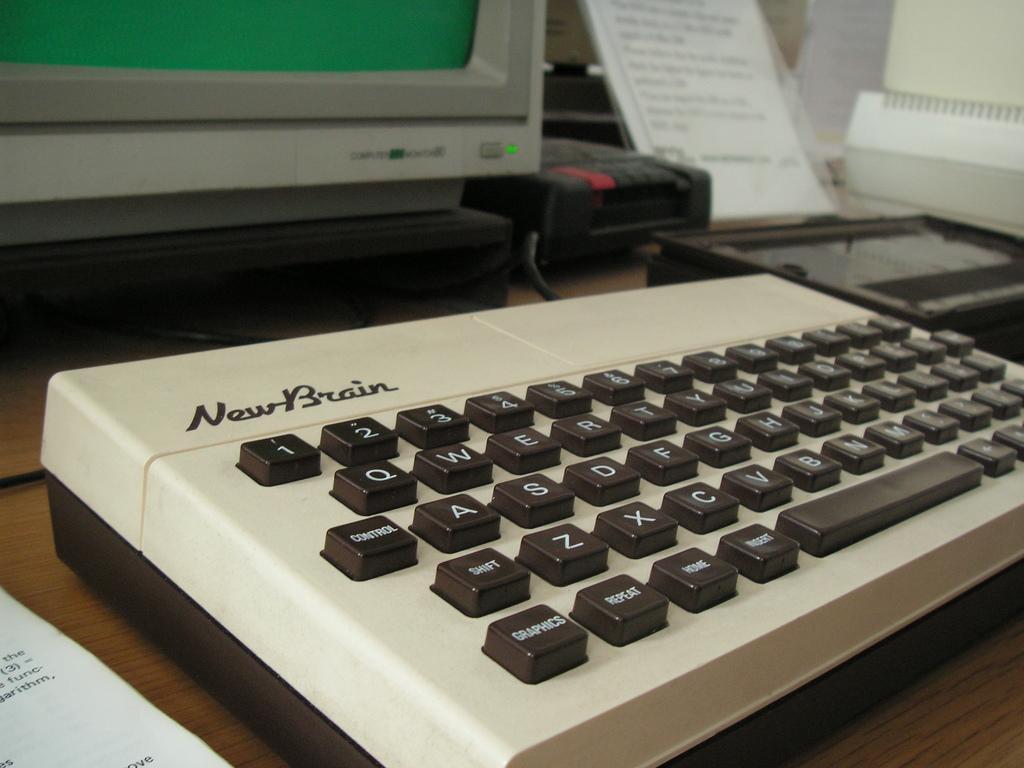In one or two sentences, can you explain what this image depicts? In this picture there is a keyboard on the table a paper and monitor. 